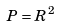Convert formula to latex. <formula><loc_0><loc_0><loc_500><loc_500>P = R ^ { 2 }</formula> 